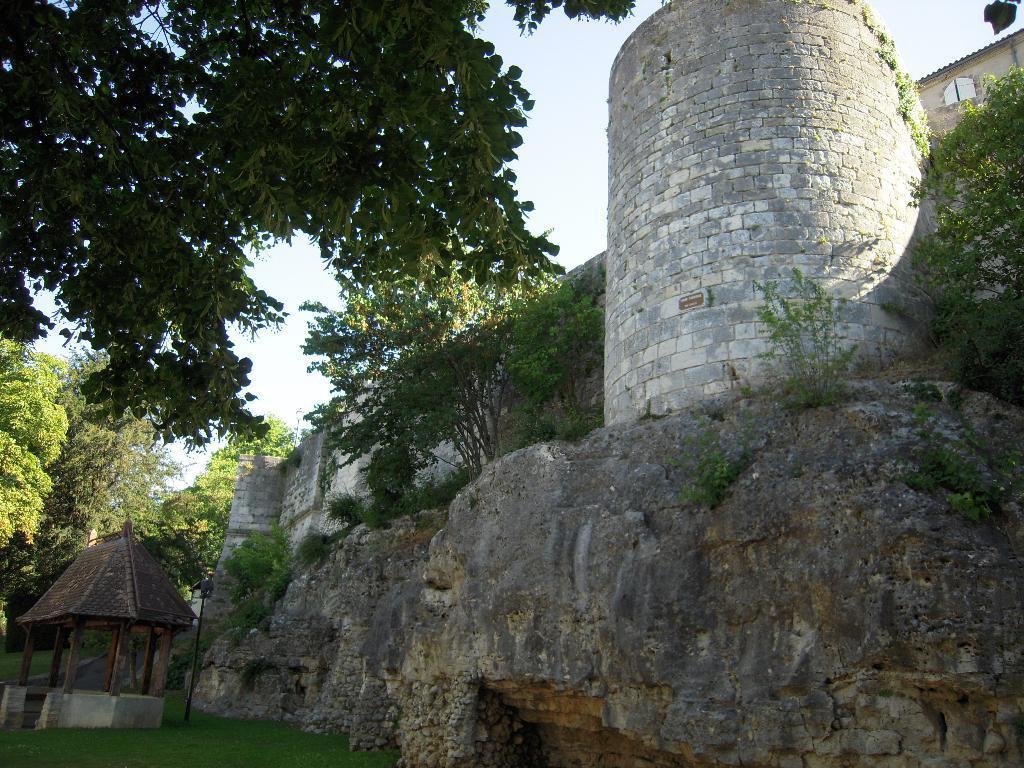Could you give a brief overview of what you see in this image? In this image we can see a structure which looks like a castle and there is a hut on the left side of the image. We can see some plants, trees and grass on the ground and at the top we can see the sky. 